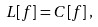<formula> <loc_0><loc_0><loc_500><loc_500>L [ f ] = C [ f ] \, ,</formula> 